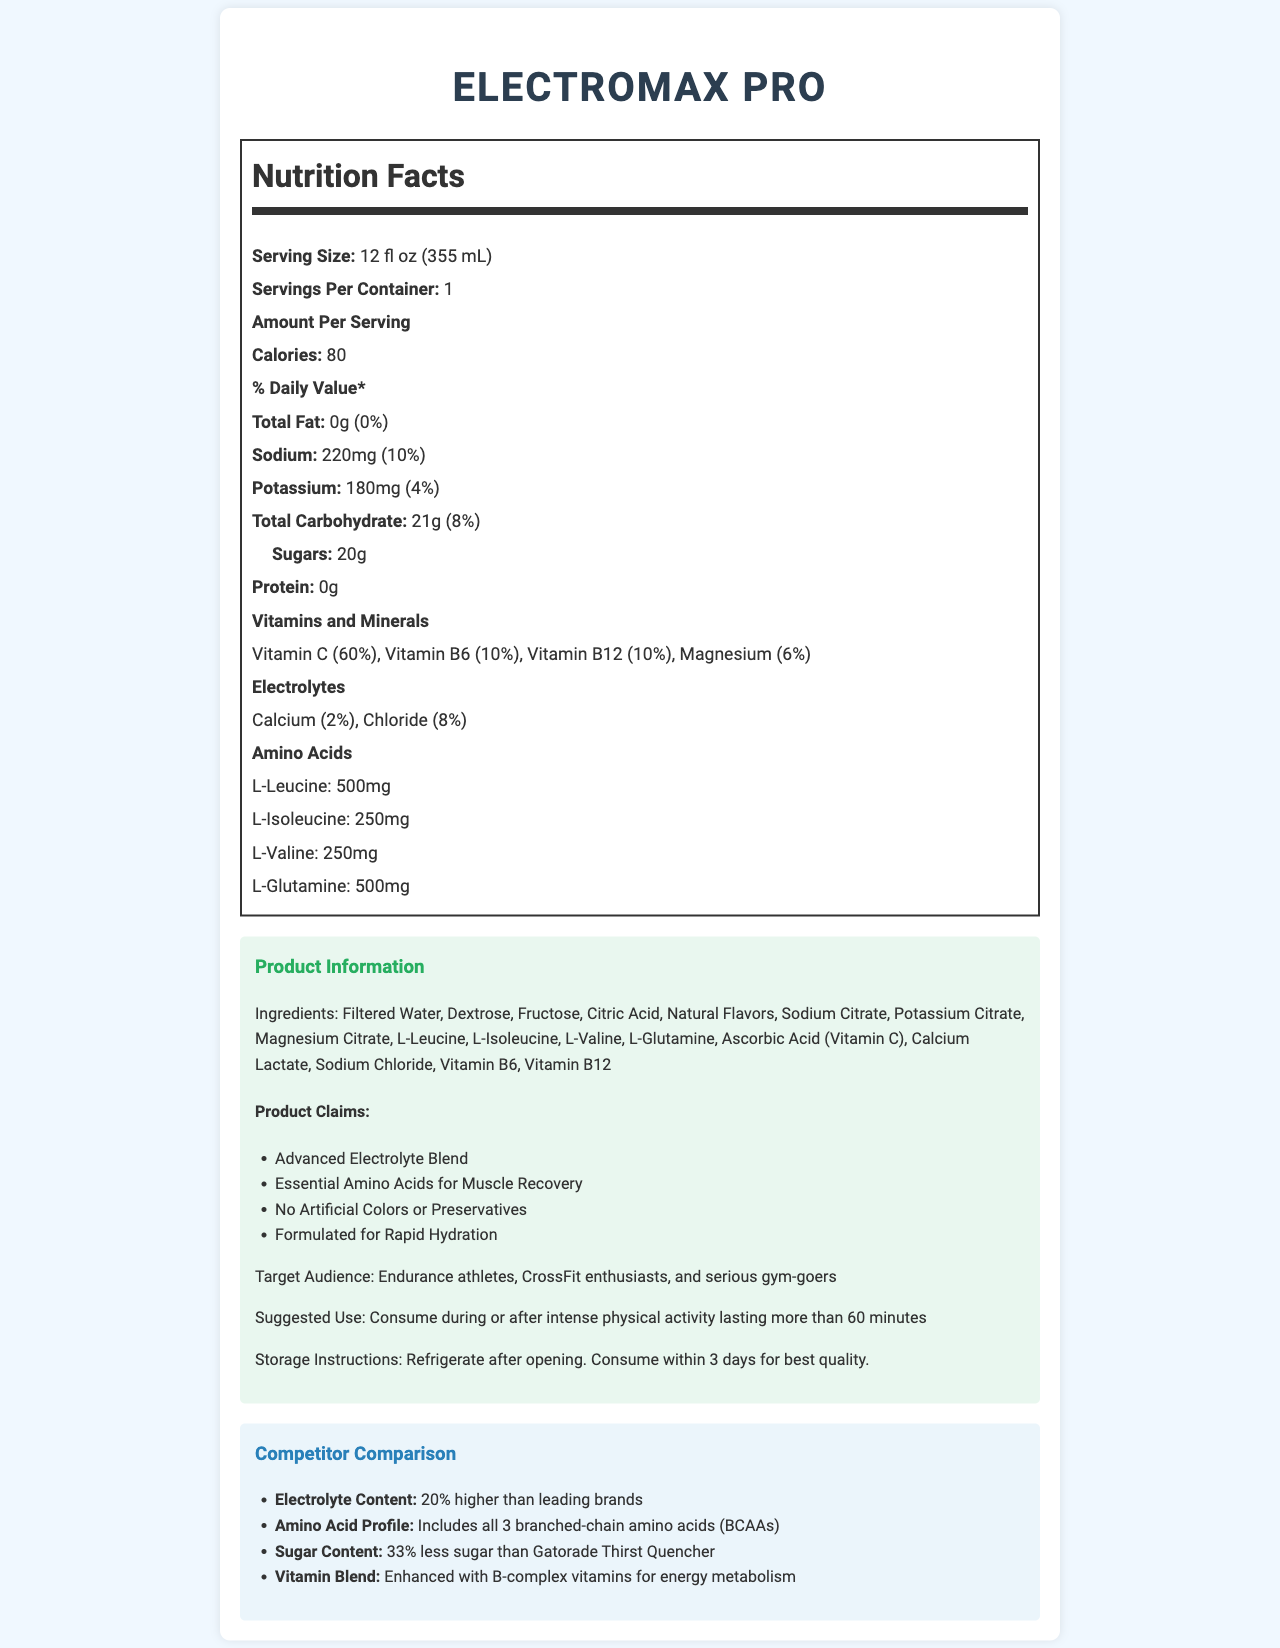what is the serving size of ElectroMax Pro? The serving size is listed at the beginning of the Nutrition Facts section of the document.
Answer: 12 fl oz (355 mL) how many servings are there per container? The number of servings per container is explicitly mentioned in the Nutrition Facts section.
Answer: 1 how many calories does one serving of ElectroMax Pro provide? The calorie count per serving is mentioned under the "Amount Per Serving" section.
Answer: 80 how much sodium is in one serving? The sodium content is noted under the "Sodium" entry in the Nutrition Facts section.
Answer: 220mg how many grams of sugar are there in one serving? The sugar content is listed under the "Total Carbohydrate" section as "Sugars".
Answer: 20g how much potassium does ElectroMax Pro contain per serving? The potassium content is described under the "Potassium" entry in the Nutrition Facts section.
Answer: 180mg what is the percentage daily value of Vitamin B6 in ElectroMax Pro? The daily value percentage for Vitamin B6 is noted in the "Vitamins and Minerals" section.
Answer: 10% how many milligrams of L-Glutamine are included in one serving? The amount of L-Glutamine is specified under the "Amino Acids" section.
Answer: 500mg which ingredient is listed third in the ingredients list? The ingredients are listed in order, and Fructose is the third item mentioned.
Answer: Fructose which of the following vitamins is not present in ElectroMax Pro? A. Vitamin C B. Vitamin D C. Vitamin B6 D. Vitamin B12 Vitamin C, Vitamin B6, and Vitamin B12 are all listed in the "Vitamins and Minerals" section, but Vitamin D is not.
Answer: B. Vitamin D what is the claim about ElectroMax Pro regarding hydration? A. Slow Hydration B. No Hydration Benefit C. Formulated for Rapid Hydration D. Formulated for Moderate Hydration Under the "Product Claims" section, it states "Formulated for Rapid Hydration".
Answer: C. Formulated for Rapid Hydration true or false: ElectroMax Pro contains artificial colors. One of the product claims under the "Product Information" section states, "No Artificial Colors or Preservatives".
Answer: False what audience is ElectroMax Pro targeting? The "Target Audience" section under "Product Information" specifies the target audience.
Answer: Endurance athletes, CrossFit enthusiasts, and serious gym-goers how much less sugar does ElectroMax Pro have compared to Gatorade Thirst Quencher, percentage-wise? The "Competitor Comparison" section mentions that ElectroMax Pro has "33% less sugar than Gatorade Thirst Quencher".
Answer: 33% less what is the main idea of the document? The document provides detailed information about ElectroMax Pro's nutritional content, ingredients, product claims, target audience, usage instructions, and comparisons with competitor products.
Answer: ElectroMax Pro is a sports performance drink designed for rapid hydration and muscle recovery, containing a blend of electrolytes, amino acids, and vitamins, with competitive advantages over leading brands. how many calories come from fat in ElectroMax Pro? The total fat is 0g, and since fat is required to contribute calories, there are no calories from fat in the product.
Answer: Zero calories what is the magnesium content in ElectroMax Pro? The magnesium content, listed in the "Vitamins and Minerals" section, is described as 6% of the daily value.
Answer: 6% of the daily value is the suggested use to consume ElectroMax Pro before intense physical activity? The suggested use is to consume during or after intense physical activity lasting more than 60 minutes.
Answer: No how should ElectroMax Pro be stored after opening? The storage instructions state these specific conditions for maintaining the best quality post-opening.
Answer: Refrigerate after opening and consume within 3 days for best quality what is the price of ElectroMax Pro? The document does not provide any information about the price of ElectroMax Pro.
Answer: Cannot be determined 